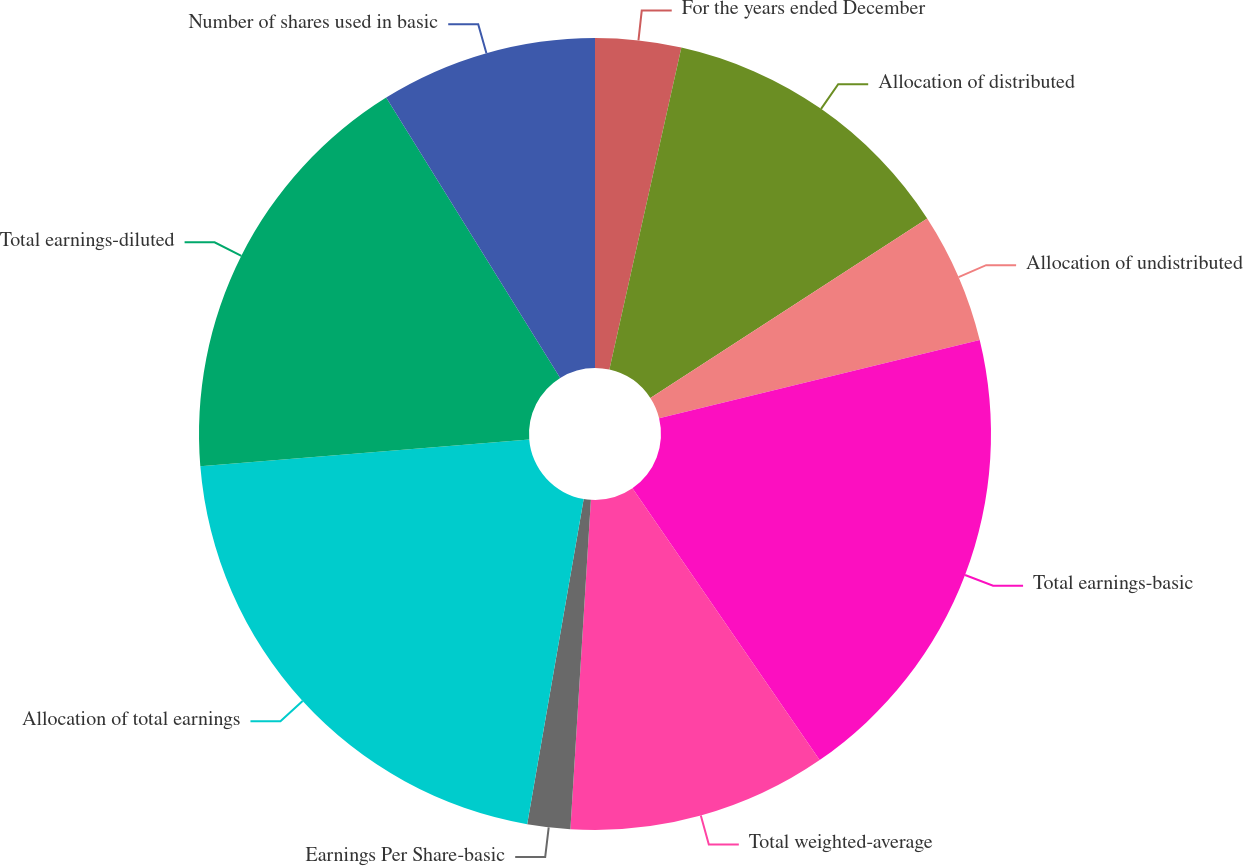<chart> <loc_0><loc_0><loc_500><loc_500><pie_chart><fcel>For the years ended December<fcel>Allocation of distributed<fcel>Allocation of undistributed<fcel>Total earnings-basic<fcel>Total weighted-average<fcel>Earnings Per Share-basic<fcel>Allocation of total earnings<fcel>Total earnings-diluted<fcel>Number of shares used in basic<nl><fcel>3.5%<fcel>12.34%<fcel>5.35%<fcel>19.21%<fcel>10.59%<fcel>1.75%<fcel>20.96%<fcel>17.46%<fcel>8.84%<nl></chart> 